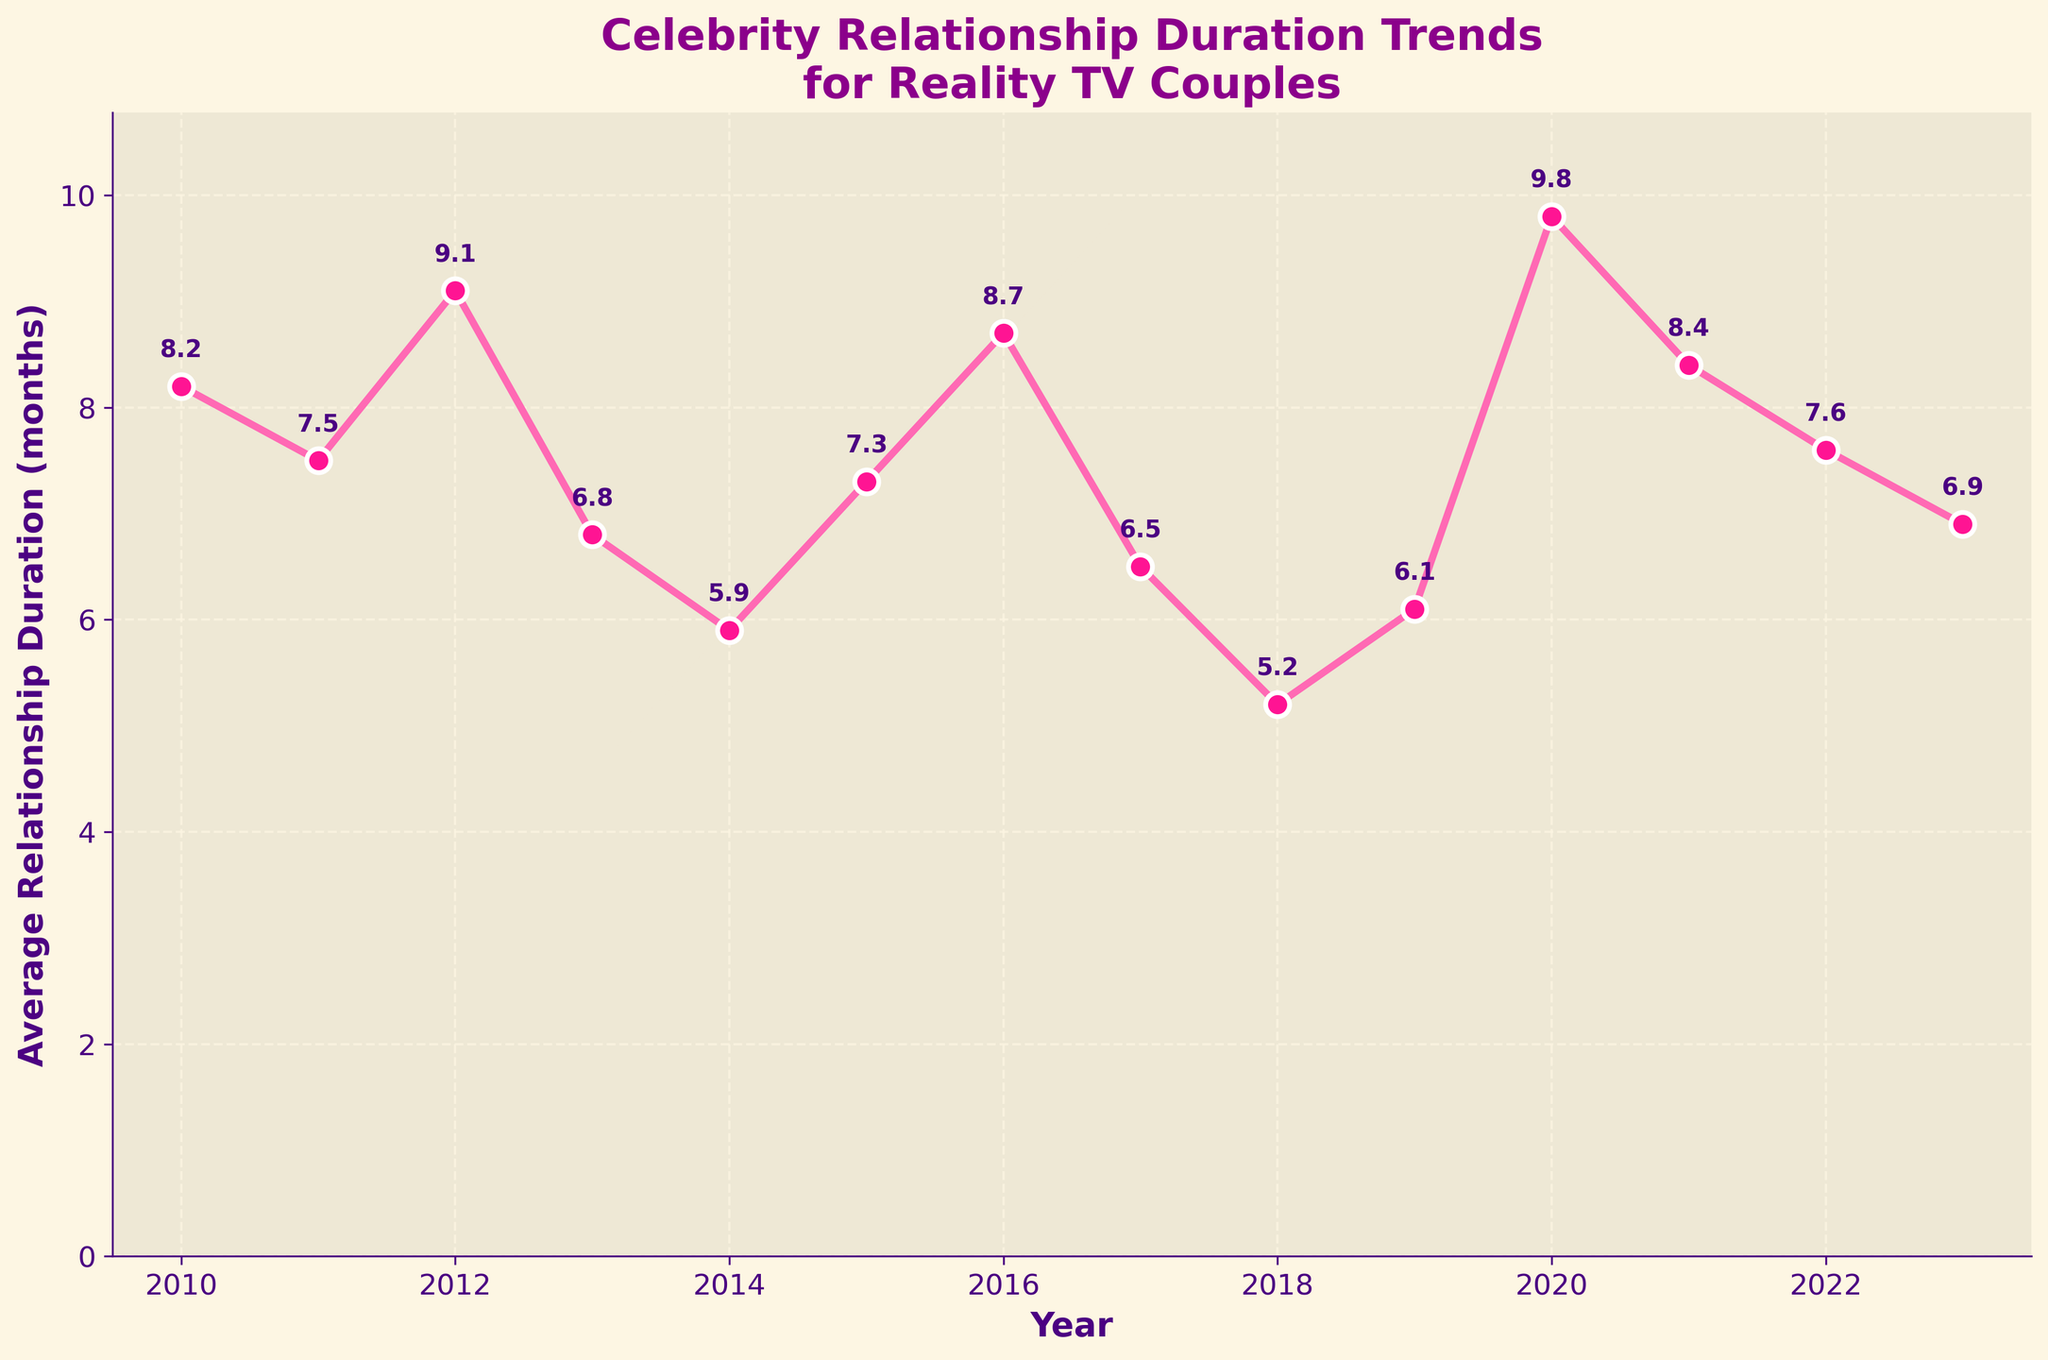Which year had the shortest average relationship duration? Looking at the plot, the lowest point on the chart occurs in 2018, where the average relationship duration is 5.2 months.
Answer: 2018 What was the average relationship duration in 2020? By referring to the annotated plot, the value for 2020 is 9.8 months.
Answer: 9.8 months Calculate the difference in average relationship duration between 2012 and 2014. The average duration in 2012 was 9.1 months and in 2014 it was 5.9 months. The difference is 9.1 - 5.9 = 3.2 months.
Answer: 3.2 months Which year had a higher average relationship duration: 2015 or 2019? From the plot, the average duration in 2015 was 7.3 months, while in 2019 it was 6.1 months. Therefore, 2015 had a higher average.
Answer: 2015 What trend do you observe in the average relationship duration from 2018 to 2020? Observing the plot, the average relationship duration increases from 5.2 months in 2018 to 9.8 months in 2020. This indicates an upward trend.
Answer: Upward trend In which year(s) did the average relationship duration drop below 6 months? Checking the annotated values on the plot, the average duration dropped below 6 months in 2014 (5.9 months) and in 2018 (5.2 months).
Answer: 2014, 2018 Compare the average relationship durations between 2011 and 2023; which one is longer? From the plot, the duration in 2011 was 7.5 months and in 2023 it was 6.9 months. Therefore, the duration in 2011 is longer.
Answer: 2011 What is the overall range of the average relationship duration values from 2010 to 2023? The highest average duration is 9.8 months (2020) and the lowest is 5.2 months (2018). Therefore, the range is 9.8 - 5.2 = 4.6 months.
Answer: 4.6 months If you average the durations for the years 2019, 2020, and 2021, what would be the result? The values are 6.1, 9.8, and 8.4 months for 2019, 2020, and 2021 respectively. The average is (6.1 + 9.8 + 8.4)/3 = 8.1 months.
Answer: 8.1 months 